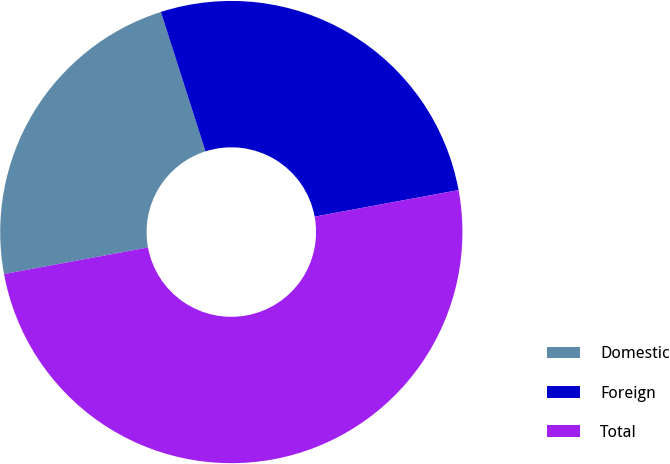Convert chart. <chart><loc_0><loc_0><loc_500><loc_500><pie_chart><fcel>Domestic<fcel>Foreign<fcel>Total<nl><fcel>22.98%<fcel>27.02%<fcel>50.0%<nl></chart> 